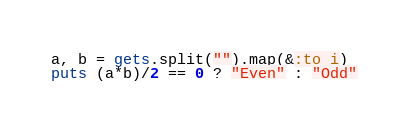<code> <loc_0><loc_0><loc_500><loc_500><_Ruby_>a, b = gets.split("").map(&:to_i)
puts (a*b)/2 == 0 ? "Even" : "Odd"</code> 